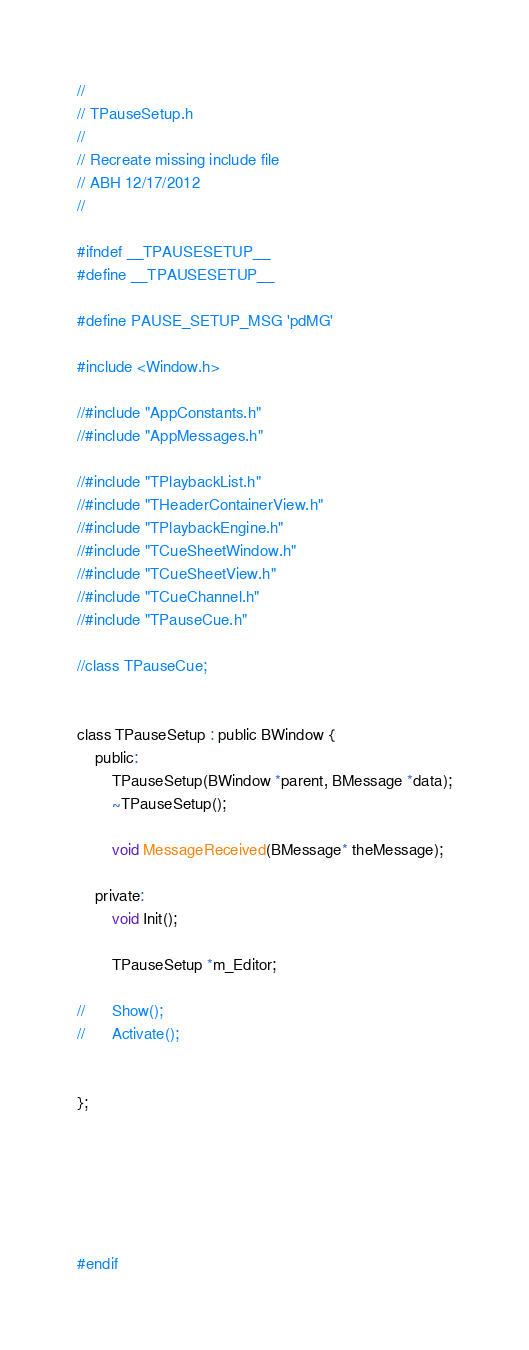<code> <loc_0><loc_0><loc_500><loc_500><_C_>//
// TPauseSetup.h
//
// Recreate missing include file
// ABH 12/17/2012
//

#ifndef __TPAUSESETUP__
#define __TPAUSESETUP__

#define PAUSE_SETUP_MSG 'pdMG'

#include <Window.h>

//#include "AppConstants.h"
//#include "AppMessages.h"

//#include "TPlaybackList.h"
//#include "THeaderContainerView.h"
//#include "TPlaybackEngine.h"
//#include "TCueSheetWindow.h"
//#include "TCueSheetView.h"
//#include "TCueChannel.h"
//#include "TPauseCue.h"

//class TPauseCue;


class TPauseSetup : public BWindow {
	public:
		TPauseSetup(BWindow *parent, BMessage *data);
		~TPauseSetup();
		
		void MessageReceived(BMessage* theMessage);
		
	private:
		void Init();
		
		TPauseSetup *m_Editor;

//		Show();
//		Activate();

	
};






#endif

</code> 